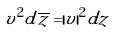Convert formula to latex. <formula><loc_0><loc_0><loc_500><loc_500>v ^ { 2 } d \overline { z } = | v | ^ { 2 } d z</formula> 